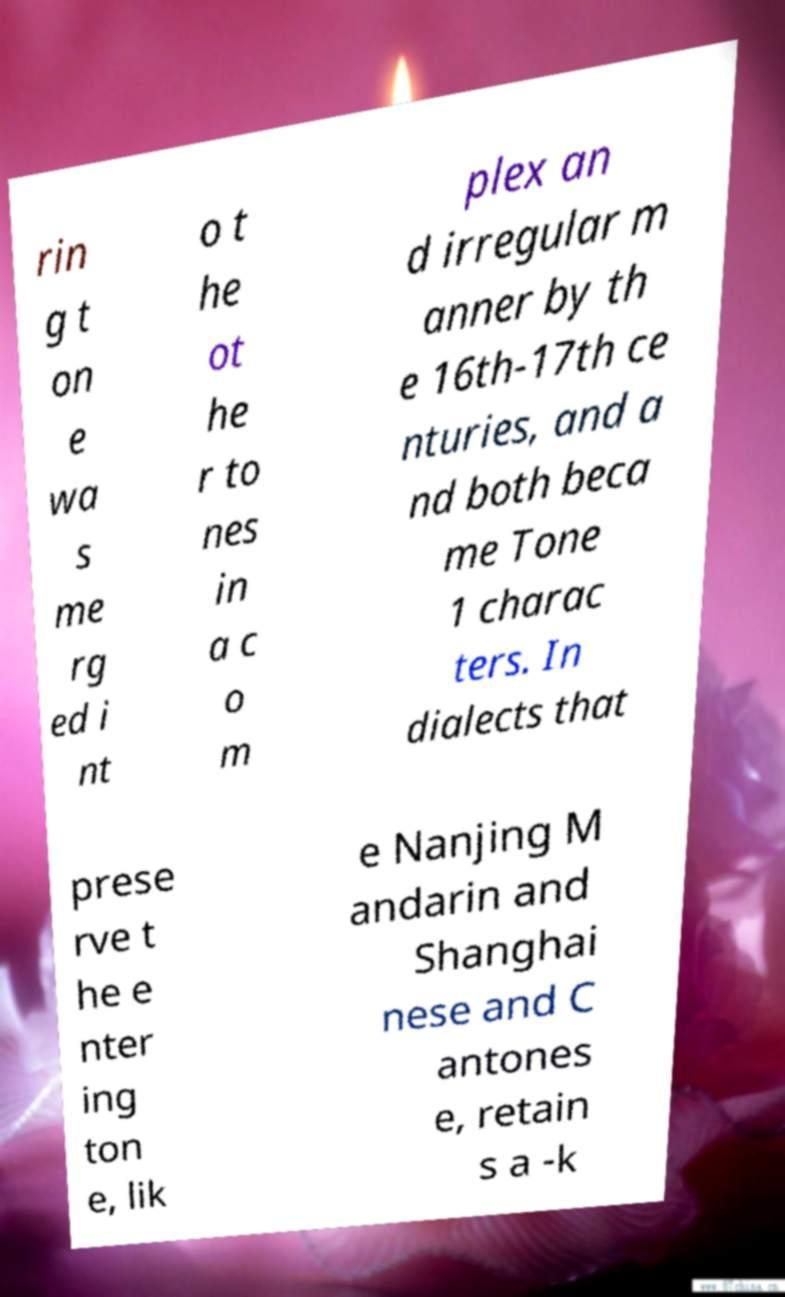Can you accurately transcribe the text from the provided image for me? rin g t on e wa s me rg ed i nt o t he ot he r to nes in a c o m plex an d irregular m anner by th e 16th-17th ce nturies, and a nd both beca me Tone 1 charac ters. In dialects that prese rve t he e nter ing ton e, lik e Nanjing M andarin and Shanghai nese and C antones e, retain s a -k 